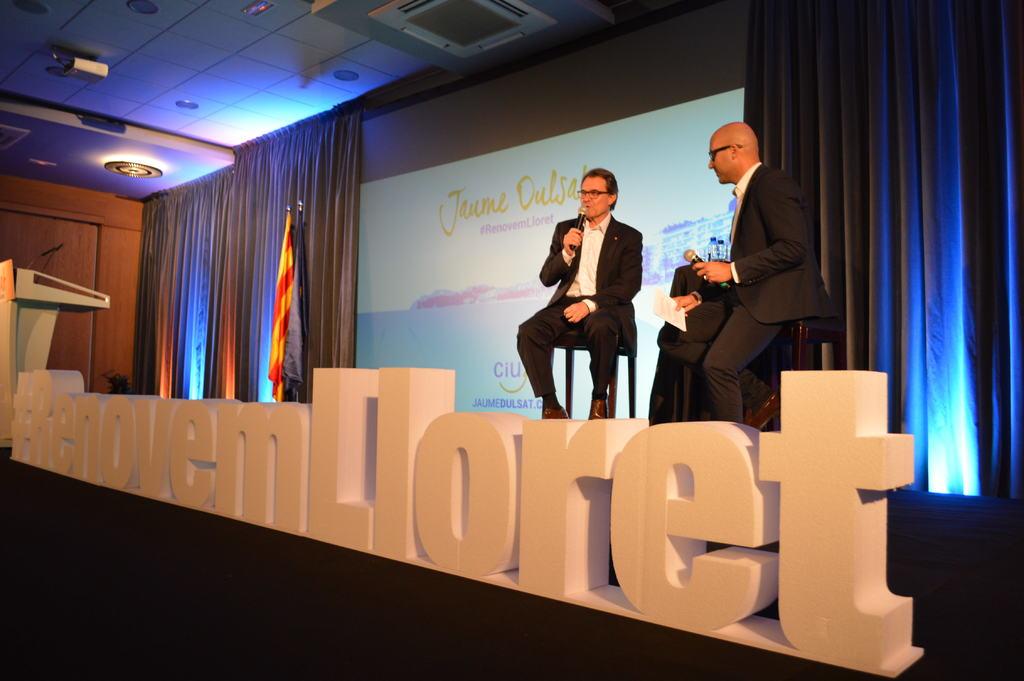What is the #?
Your answer should be very brief. Renovemlloret. 